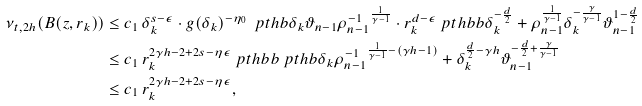Convert formula to latex. <formula><loc_0><loc_0><loc_500><loc_500>\nu _ { t , 2 h } ( B ( z , r _ { k } ) ) & \leq c _ { 1 } \, \delta _ { k } ^ { s - \epsilon } \cdot g ( \delta _ { k } ) ^ { - \eta _ { 0 } } \, \ p t h b { \delta _ { k } \vartheta _ { n - 1 } \rho _ { n - 1 } ^ { - 1 } } ^ { \frac { 1 } { \gamma - 1 } } \cdot r _ { k } ^ { d - \epsilon } \ p t h b b { \delta _ { k } ^ { - \frac { d } { 2 } } + \rho _ { n - 1 } ^ { \frac { 1 } { \gamma - 1 } } \delta _ { k } ^ { - \frac { \gamma } { \gamma - 1 } } \vartheta _ { n - 1 } ^ { 1 - \frac { d } { 2 } } } \\ & \leq c _ { 1 } \, r _ { k } ^ { 2 \gamma h - 2 + 2 s - \eta \epsilon } \ p t h b b { \ p t h b { \delta _ { k } \rho _ { n - 1 } ^ { - 1 } } ^ { \frac { 1 } { \gamma - 1 } - ( \gamma h - 1 ) } + \delta _ { k } ^ { \frac { d } { 2 } - \gamma h } \vartheta _ { n - 1 } ^ { - \frac { d } { 2 } + \frac { \gamma } { \gamma - 1 } } } \\ & \leq c _ { 1 } \, r _ { k } ^ { 2 \gamma h - 2 + 2 s - \eta \epsilon } ,</formula> 